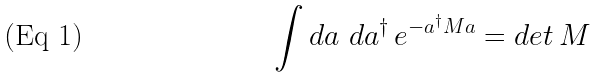Convert formula to latex. <formula><loc_0><loc_0><loc_500><loc_500>\int d a \text { } d a ^ { \dagger } \, e ^ { - a ^ { \dagger } M a } = d e t \, M</formula> 